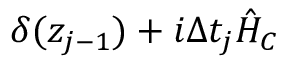<formula> <loc_0><loc_0><loc_500><loc_500>\delta ( z _ { j - 1 } ) + i \Delta t _ { j } \hat { H } _ { C }</formula> 